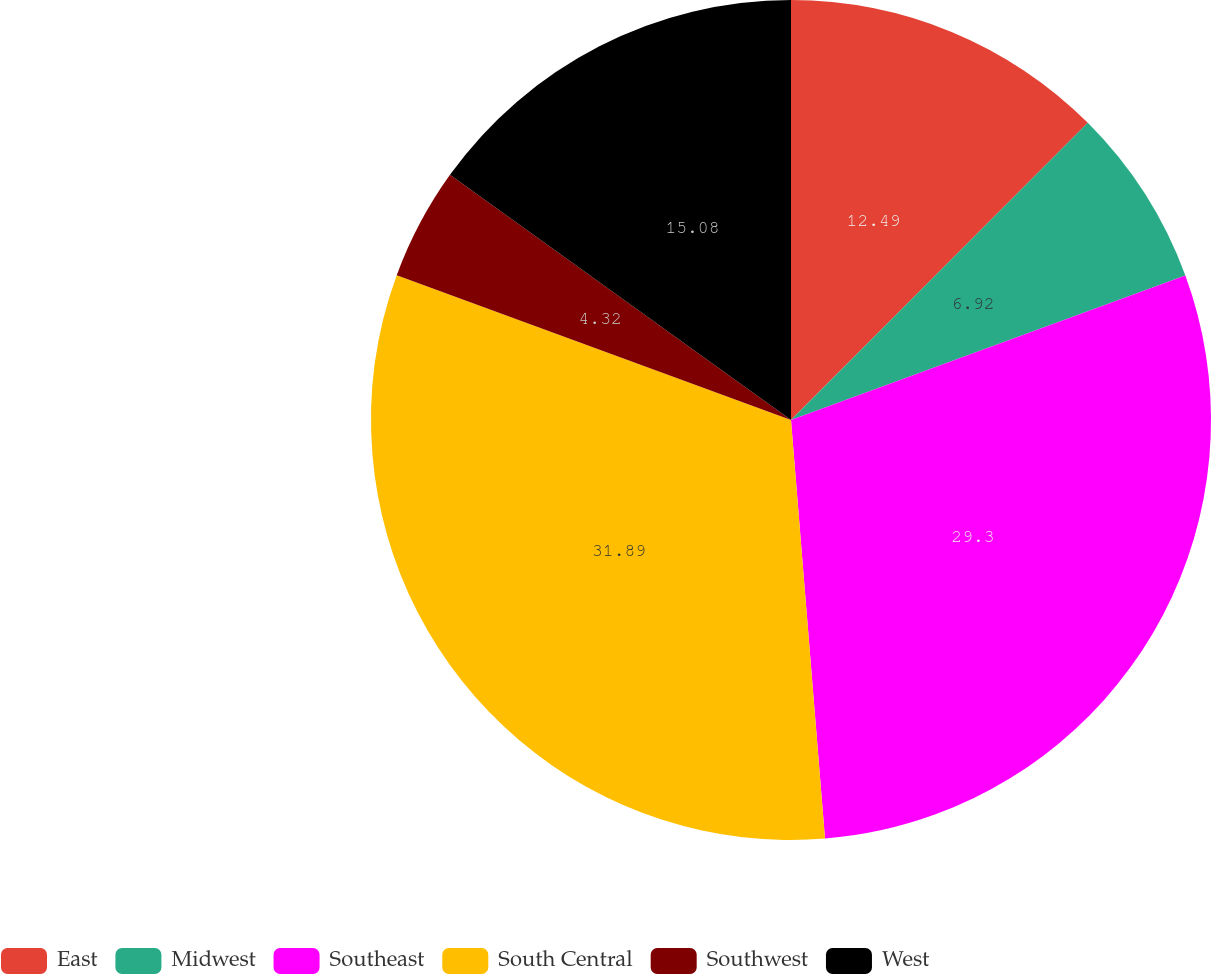<chart> <loc_0><loc_0><loc_500><loc_500><pie_chart><fcel>East<fcel>Midwest<fcel>Southeast<fcel>South Central<fcel>Southwest<fcel>West<nl><fcel>12.49%<fcel>6.92%<fcel>29.3%<fcel>31.89%<fcel>4.32%<fcel>15.08%<nl></chart> 